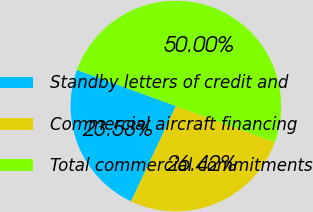Convert chart to OTSL. <chart><loc_0><loc_0><loc_500><loc_500><pie_chart><fcel>Standby letters of credit and<fcel>Commercial aircraft financing<fcel>Total commercial commitments<nl><fcel>23.58%<fcel>26.42%<fcel>50.0%<nl></chart> 